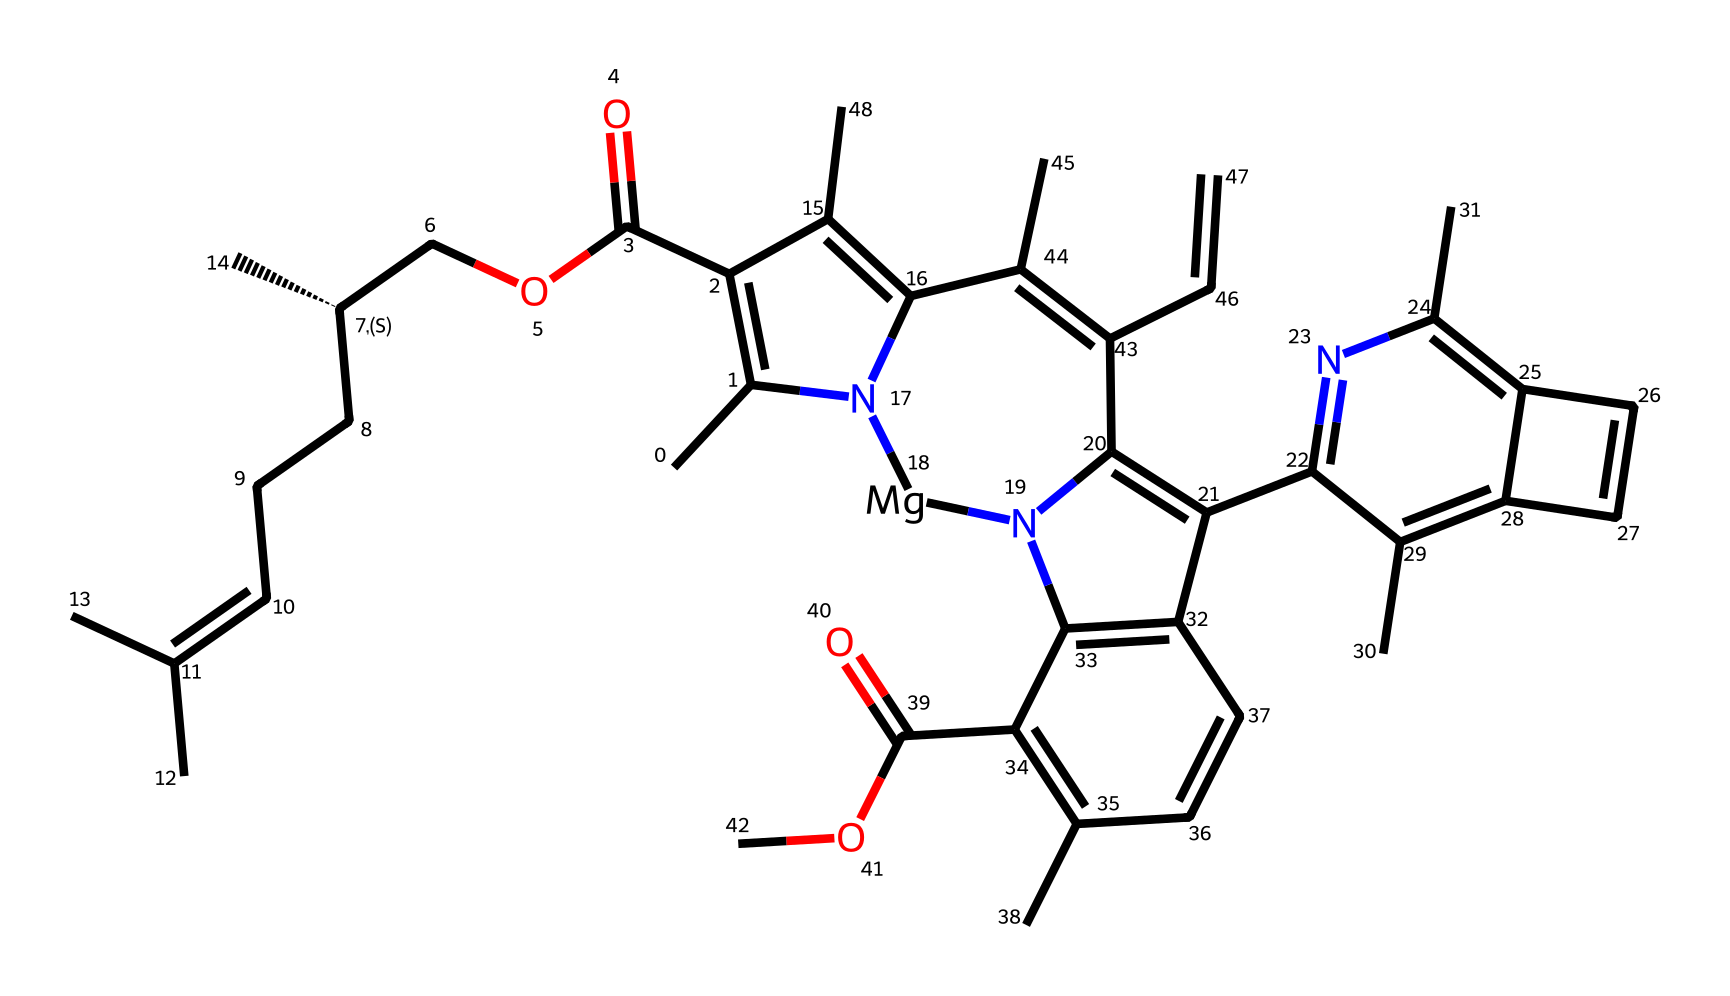What is the functional group present responsible for its ester characteristics? Looking at the molecular structure, we can identify the carbonyl (C=O) adjacent to an oxygen atom connected to a carbon chain, which indicates that this chemical contains an ester functional group.
Answer: ester How many nitrogen atoms are present in the compound? By examining the SMILES representation, nitrogen atoms are marked and can be counted. There are three nitrogen atoms present in the chemical structure.
Answer: three Which part of the molecule is likely responsible for its color in grass stains? The presence of multiple conjugated systems (double bonds) and the cyclic structures (rings) in the compound suggests that these features contribute to color due to light absorption, typically found in pigments.
Answer: cyclic structures How many rings are present in the molecular structure? By breaking down the SMILES notation, we can identify the circular formations in the structure. This molecule contains three distinct rings.
Answer: three What might be the solubility characteristic of this compound in organic solvents? Given the presence of both polar (e.g., the ester group) and nonpolar regions (e.g., hydrocarbon chains), this compound is likely to be more soluble in organic solvents than in water.
Answer: more soluble in organic solvents What kind of derivative is implied in the chemical structure here? The structure reveals the features typical of a derivative obtained from a natural product, as noticed by the complex arrangement and functional groups combining features from different classes of organic compounds.
Answer: natural product derivative 